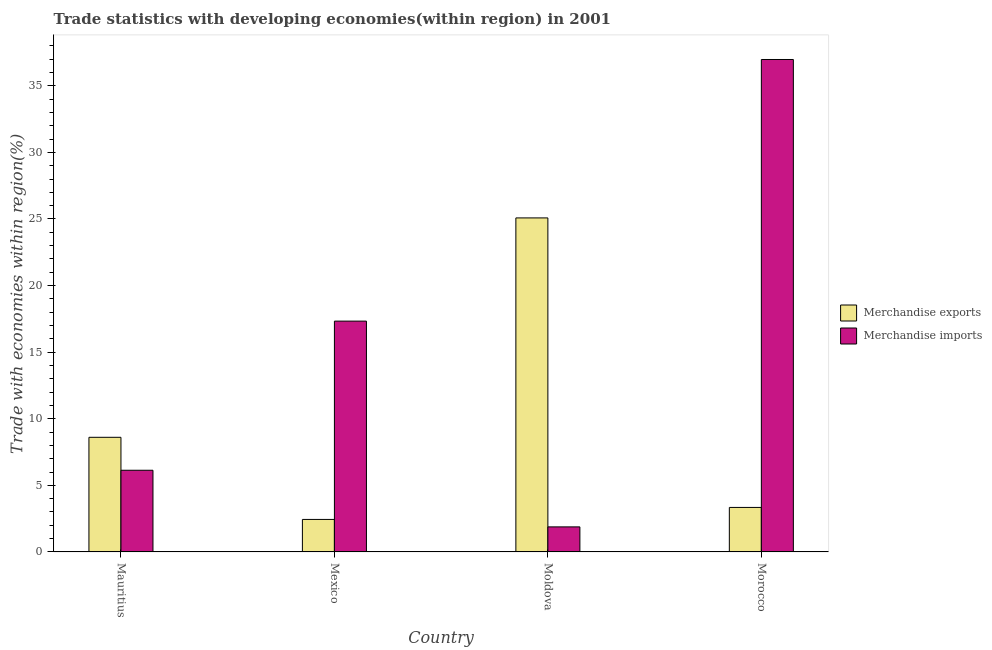Are the number of bars per tick equal to the number of legend labels?
Keep it short and to the point. Yes. Are the number of bars on each tick of the X-axis equal?
Keep it short and to the point. Yes. How many bars are there on the 1st tick from the right?
Make the answer very short. 2. What is the label of the 1st group of bars from the left?
Keep it short and to the point. Mauritius. In how many cases, is the number of bars for a given country not equal to the number of legend labels?
Your answer should be compact. 0. What is the merchandise imports in Mauritius?
Make the answer very short. 6.13. Across all countries, what is the maximum merchandise imports?
Give a very brief answer. 36.97. Across all countries, what is the minimum merchandise exports?
Provide a short and direct response. 2.44. In which country was the merchandise imports maximum?
Give a very brief answer. Morocco. What is the total merchandise exports in the graph?
Offer a very short reply. 39.47. What is the difference between the merchandise exports in Mexico and that in Morocco?
Make the answer very short. -0.9. What is the difference between the merchandise imports in Mexico and the merchandise exports in Morocco?
Your answer should be compact. 13.99. What is the average merchandise exports per country?
Make the answer very short. 9.87. What is the difference between the merchandise exports and merchandise imports in Mauritius?
Offer a very short reply. 2.47. In how many countries, is the merchandise imports greater than 16 %?
Give a very brief answer. 2. What is the ratio of the merchandise exports in Mauritius to that in Mexico?
Ensure brevity in your answer.  3.53. Is the merchandise exports in Mexico less than that in Morocco?
Keep it short and to the point. Yes. Is the difference between the merchandise imports in Mauritius and Morocco greater than the difference between the merchandise exports in Mauritius and Morocco?
Provide a succinct answer. No. What is the difference between the highest and the second highest merchandise exports?
Your answer should be very brief. 16.47. What is the difference between the highest and the lowest merchandise imports?
Offer a very short reply. 35.09. In how many countries, is the merchandise imports greater than the average merchandise imports taken over all countries?
Provide a succinct answer. 2. What does the 2nd bar from the right in Mexico represents?
Offer a terse response. Merchandise exports. Are all the bars in the graph horizontal?
Give a very brief answer. No. How many countries are there in the graph?
Offer a very short reply. 4. Are the values on the major ticks of Y-axis written in scientific E-notation?
Your answer should be very brief. No. Does the graph contain any zero values?
Give a very brief answer. No. What is the title of the graph?
Make the answer very short. Trade statistics with developing economies(within region) in 2001. Does "Primary" appear as one of the legend labels in the graph?
Offer a very short reply. No. What is the label or title of the X-axis?
Keep it short and to the point. Country. What is the label or title of the Y-axis?
Your response must be concise. Trade with economies within region(%). What is the Trade with economies within region(%) in Merchandise exports in Mauritius?
Provide a short and direct response. 8.61. What is the Trade with economies within region(%) of Merchandise imports in Mauritius?
Make the answer very short. 6.13. What is the Trade with economies within region(%) in Merchandise exports in Mexico?
Ensure brevity in your answer.  2.44. What is the Trade with economies within region(%) in Merchandise imports in Mexico?
Give a very brief answer. 17.33. What is the Trade with economies within region(%) of Merchandise exports in Moldova?
Your answer should be very brief. 25.08. What is the Trade with economies within region(%) of Merchandise imports in Moldova?
Provide a short and direct response. 1.88. What is the Trade with economies within region(%) in Merchandise exports in Morocco?
Your answer should be compact. 3.34. What is the Trade with economies within region(%) of Merchandise imports in Morocco?
Offer a terse response. 36.97. Across all countries, what is the maximum Trade with economies within region(%) in Merchandise exports?
Make the answer very short. 25.08. Across all countries, what is the maximum Trade with economies within region(%) in Merchandise imports?
Ensure brevity in your answer.  36.97. Across all countries, what is the minimum Trade with economies within region(%) in Merchandise exports?
Provide a short and direct response. 2.44. Across all countries, what is the minimum Trade with economies within region(%) of Merchandise imports?
Make the answer very short. 1.88. What is the total Trade with economies within region(%) in Merchandise exports in the graph?
Provide a succinct answer. 39.47. What is the total Trade with economies within region(%) of Merchandise imports in the graph?
Make the answer very short. 62.32. What is the difference between the Trade with economies within region(%) of Merchandise exports in Mauritius and that in Mexico?
Your response must be concise. 6.17. What is the difference between the Trade with economies within region(%) in Merchandise imports in Mauritius and that in Mexico?
Your answer should be very brief. -11.2. What is the difference between the Trade with economies within region(%) of Merchandise exports in Mauritius and that in Moldova?
Give a very brief answer. -16.47. What is the difference between the Trade with economies within region(%) of Merchandise imports in Mauritius and that in Moldova?
Keep it short and to the point. 4.25. What is the difference between the Trade with economies within region(%) in Merchandise exports in Mauritius and that in Morocco?
Keep it short and to the point. 5.27. What is the difference between the Trade with economies within region(%) in Merchandise imports in Mauritius and that in Morocco?
Your response must be concise. -30.84. What is the difference between the Trade with economies within region(%) of Merchandise exports in Mexico and that in Moldova?
Provide a succinct answer. -22.64. What is the difference between the Trade with economies within region(%) in Merchandise imports in Mexico and that in Moldova?
Provide a short and direct response. 15.45. What is the difference between the Trade with economies within region(%) of Merchandise exports in Mexico and that in Morocco?
Provide a succinct answer. -0.9. What is the difference between the Trade with economies within region(%) of Merchandise imports in Mexico and that in Morocco?
Provide a short and direct response. -19.64. What is the difference between the Trade with economies within region(%) in Merchandise exports in Moldova and that in Morocco?
Provide a succinct answer. 21.74. What is the difference between the Trade with economies within region(%) in Merchandise imports in Moldova and that in Morocco?
Offer a terse response. -35.09. What is the difference between the Trade with economies within region(%) in Merchandise exports in Mauritius and the Trade with economies within region(%) in Merchandise imports in Mexico?
Make the answer very short. -8.72. What is the difference between the Trade with economies within region(%) of Merchandise exports in Mauritius and the Trade with economies within region(%) of Merchandise imports in Moldova?
Offer a terse response. 6.73. What is the difference between the Trade with economies within region(%) in Merchandise exports in Mauritius and the Trade with economies within region(%) in Merchandise imports in Morocco?
Offer a terse response. -28.37. What is the difference between the Trade with economies within region(%) in Merchandise exports in Mexico and the Trade with economies within region(%) in Merchandise imports in Moldova?
Your response must be concise. 0.56. What is the difference between the Trade with economies within region(%) in Merchandise exports in Mexico and the Trade with economies within region(%) in Merchandise imports in Morocco?
Ensure brevity in your answer.  -34.53. What is the difference between the Trade with economies within region(%) in Merchandise exports in Moldova and the Trade with economies within region(%) in Merchandise imports in Morocco?
Your answer should be compact. -11.89. What is the average Trade with economies within region(%) in Merchandise exports per country?
Provide a short and direct response. 9.87. What is the average Trade with economies within region(%) in Merchandise imports per country?
Keep it short and to the point. 15.58. What is the difference between the Trade with economies within region(%) in Merchandise exports and Trade with economies within region(%) in Merchandise imports in Mauritius?
Your answer should be compact. 2.47. What is the difference between the Trade with economies within region(%) in Merchandise exports and Trade with economies within region(%) in Merchandise imports in Mexico?
Ensure brevity in your answer.  -14.89. What is the difference between the Trade with economies within region(%) in Merchandise exports and Trade with economies within region(%) in Merchandise imports in Moldova?
Make the answer very short. 23.2. What is the difference between the Trade with economies within region(%) in Merchandise exports and Trade with economies within region(%) in Merchandise imports in Morocco?
Keep it short and to the point. -33.63. What is the ratio of the Trade with economies within region(%) of Merchandise exports in Mauritius to that in Mexico?
Offer a terse response. 3.53. What is the ratio of the Trade with economies within region(%) of Merchandise imports in Mauritius to that in Mexico?
Your answer should be compact. 0.35. What is the ratio of the Trade with economies within region(%) of Merchandise exports in Mauritius to that in Moldova?
Keep it short and to the point. 0.34. What is the ratio of the Trade with economies within region(%) in Merchandise imports in Mauritius to that in Moldova?
Make the answer very short. 3.26. What is the ratio of the Trade with economies within region(%) of Merchandise exports in Mauritius to that in Morocco?
Offer a very short reply. 2.58. What is the ratio of the Trade with economies within region(%) in Merchandise imports in Mauritius to that in Morocco?
Keep it short and to the point. 0.17. What is the ratio of the Trade with economies within region(%) in Merchandise exports in Mexico to that in Moldova?
Keep it short and to the point. 0.1. What is the ratio of the Trade with economies within region(%) of Merchandise imports in Mexico to that in Moldova?
Your answer should be compact. 9.21. What is the ratio of the Trade with economies within region(%) of Merchandise exports in Mexico to that in Morocco?
Offer a terse response. 0.73. What is the ratio of the Trade with economies within region(%) in Merchandise imports in Mexico to that in Morocco?
Provide a succinct answer. 0.47. What is the ratio of the Trade with economies within region(%) of Merchandise exports in Moldova to that in Morocco?
Your response must be concise. 7.51. What is the ratio of the Trade with economies within region(%) of Merchandise imports in Moldova to that in Morocco?
Your answer should be compact. 0.05. What is the difference between the highest and the second highest Trade with economies within region(%) of Merchandise exports?
Keep it short and to the point. 16.47. What is the difference between the highest and the second highest Trade with economies within region(%) in Merchandise imports?
Keep it short and to the point. 19.64. What is the difference between the highest and the lowest Trade with economies within region(%) of Merchandise exports?
Offer a terse response. 22.64. What is the difference between the highest and the lowest Trade with economies within region(%) in Merchandise imports?
Offer a terse response. 35.09. 